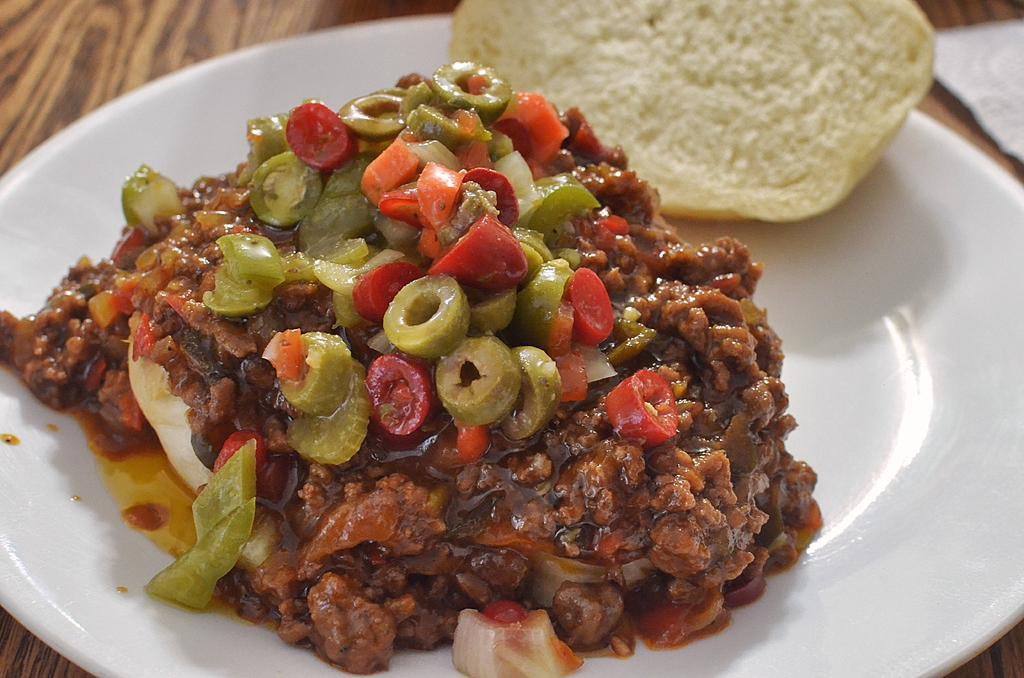What is the main object in the center of the image? There is a plate in the center of the image. What is on the plate? The plate contains food items. How many boys are playing on the ground in the image? There are no boys or any reference to a ground in the image; it only features a plate with food items. 